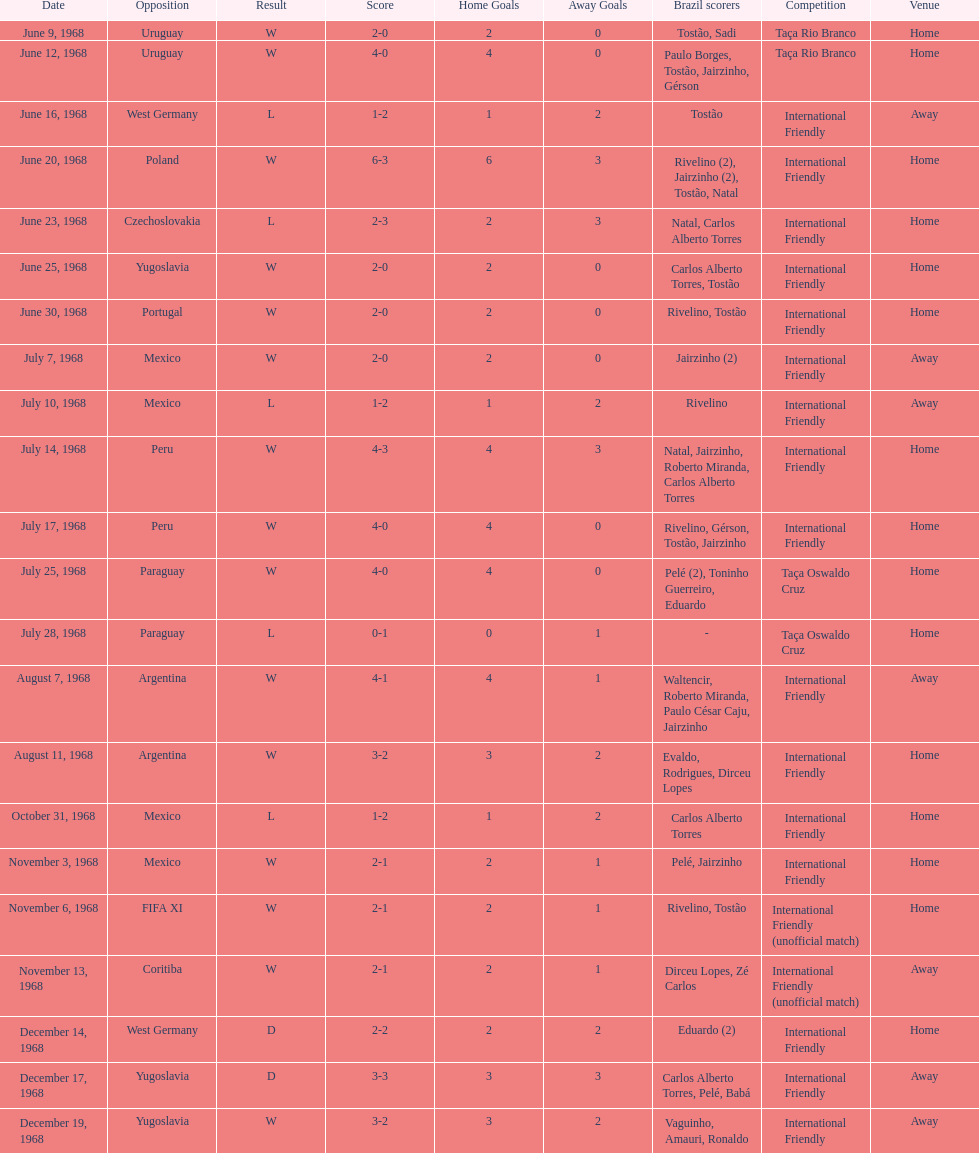What year has the highest scoring game? 1968. 